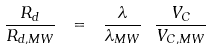Convert formula to latex. <formula><loc_0><loc_0><loc_500><loc_500>\frac { R _ { d } } { R _ { d , M W } } \ = \ \frac { \lambda } { \lambda _ { M W } } \ \frac { V _ { C } } { V _ { C , M W } }</formula> 